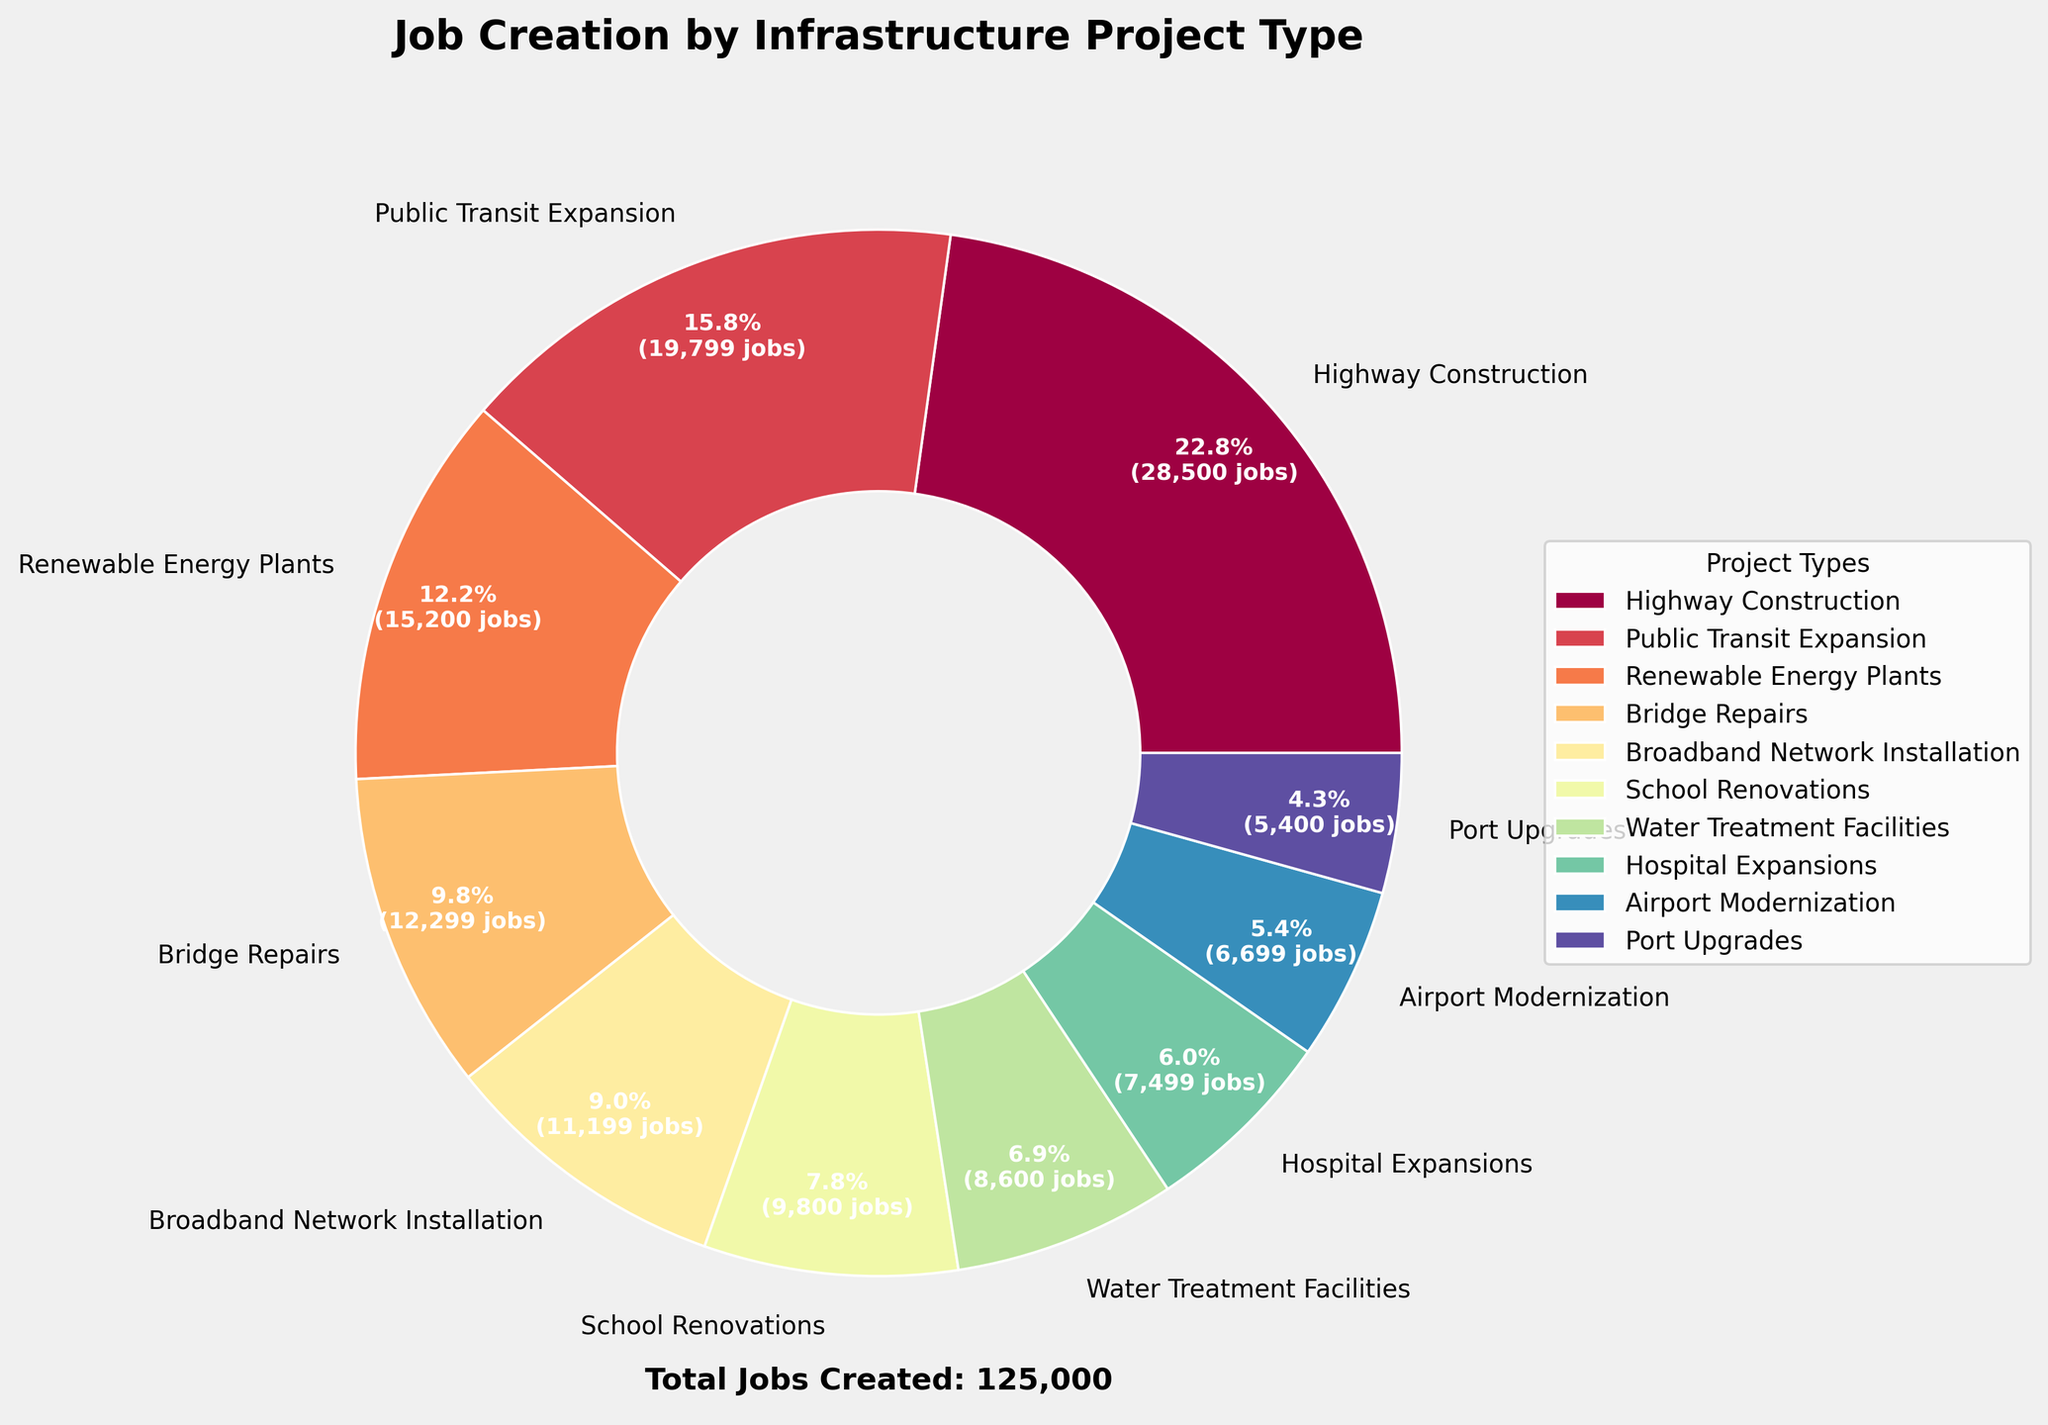What project type created the most jobs? By examining the pie chart, we can see that "Highway Construction" has the largest wedge indicating it created the most jobs.
Answer: Highway Construction How many jobs were created by "Public Transit Expansion" and "Renewable Energy Plants" combined? From the pie chart, "Public Transit Expansion" created 19,800 jobs and "Renewable Energy Plants" created 15,200 jobs. Adding these together gives 19,800 + 15,200 = 35,000 jobs.
Answer: 35,000 Is the number of jobs created by "Bridge Repairs" greater than that created by "Airport Modernization" and "Port Upgrades" combined? "Bridge Repairs" created 12,300 jobs, "Airport Modernization" created 6,700 jobs, and "Port Upgrades" created 5,400 jobs. Combining the latter two gives 6,700 + 5,400 = 12,100 jobs, which is less than 12,300 jobs created by "Bridge Repairs".
Answer: Yes How does the percentage of jobs created by "Broadband Network Installation" compare to that of "School Renovations"? From the pie chart, "Broadband Network Installation" has 11,200 jobs and "School Renovations" has 9,800 jobs. Calculating the percentages over the total jobs: (11,200 / 126,500) * 100 ≈ 8.9% and (9,800 / 126,500) * 100 ≈ 7.7%. The percentage for "Broadband Network Installation" is higher.
Answer: Broadband Network Installation What is the smallest job creator among the project types and how many jobs did it create? The smallest wedge in the pie chart corresponds to "Port Upgrades," which created 5,400 jobs.
Answer: Port Upgrades Which project type created more jobs: "Hospital Expansions" or "Water Treatment Facilities"? From the pie chart, "Hospital Expansions" created 7,500 jobs while "Water Treatment Facilities" created 8,600 jobs. Therefore, "Water Treatment Facilities" created more jobs.
Answer: Water Treatment Facilities Approximately, what percentage of total jobs were created by "Highway Construction"? The pie chart shows "Highway Construction" created 28,500 jobs out of the total 126,500 jobs. Calculating the percentage: (28,500 / 126,500) * 100 ≈ 22.5%.
Answer: 22.5% How many more jobs were created by "Renewable Energy Plants" compared to "Hospital Expansions"? "Renewable Energy Plants" created 15,200 jobs and "Hospital Expansions" created 7,500 jobs. The difference is 15,200 - 7,500 = 7,700 jobs.
Answer: 7,700 What's the total number of jobs created by "Broadband Network Installation," "School Renovations," and "Hospital Expansions"? Adding the figures from the pie chart: "Broadband Network Installation" (11,200) + "School Renovations" (9,800) + "Hospital Expansions" (7,500) = 11,200 + 9,800 + 7,500 = 28,500 jobs.
Answer: 28,500 Between "Bridge Repairs" and "Public Transit Expansion", which created a higher percentage of the total jobs and by how much? From the pie chart, "Bridge Repairs" created 12,300 jobs and "Public Transit Expansion" created 19,800 jobs. Calculating the percentages: (12,300 / 126,500) * 100 ≈ 9.7% for "Bridge Repairs" and (19,800 / 126,500) * 100 ≈ 15.6% for "Public Transit Expansion". The difference in percentage is 15.6% - 9.7% = 5.9%.
Answer: Public Transit Expansion by 5.9% 